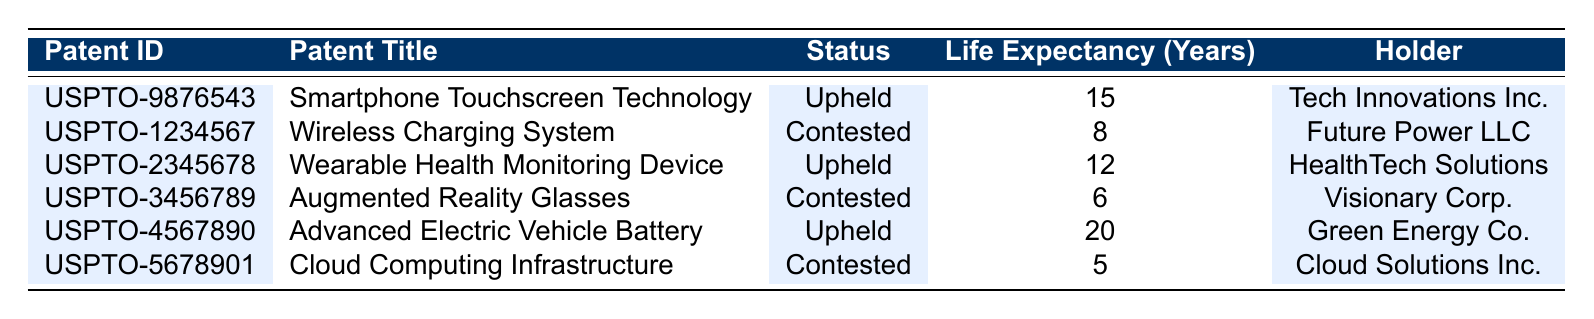What is the life expectancy of the patent titled "Advanced Electric Vehicle Battery"? The life expectancy for the patent "Advanced Electric Vehicle Battery" is directly provided in the table under the "Life Expectancy (Years)" column associated with its "Patent ID." It is listed as 20 years.
Answer: 20 How many patents in the table have a life expectancy of more than 15 years? To find this, we look at the "Life Expectancy (Years)" column for each patent. Only the "Advanced Electric Vehicle Battery" has a life expectancy of 20 years, and "Smartphone Touchscreen Technology" has 15 years. Since we want more than 15 years, we only count the "Advanced Electric Vehicle Battery." Thus, there is one patent.
Answer: 1 Is the patent titled "Cloud Computing Infrastructure" upheld? The "Cloud Computing Infrastructure" patent is listed in the "Status" column as "contested." Therefore, it is not upheld.
Answer: No What is the average life expectancy of the patents that are upheld? The life expectancies of the upheld patents are 15, 12, and 20 years (for "Smartphone Touchscreen Technology," "Wearable Health Monitoring Device," and "Advanced Electric Vehicle Battery," respectively). To calculate the average, we sum these values: 15 + 12 + 20 = 47. Then divide by the number of upheld patents (3): 47 / 3 = 15.67 years.
Answer: 15.67 Which company holds the patent with the shortest life expectancy? From the table, we examine the "Life Expectancy (Years)" values. The shortest life expectancy is 5 years, which belongs to the "Cloud Computing Infrastructure." Hence, the holder of this patent is "Cloud Solutions Inc."
Answer: Cloud Solutions Inc 